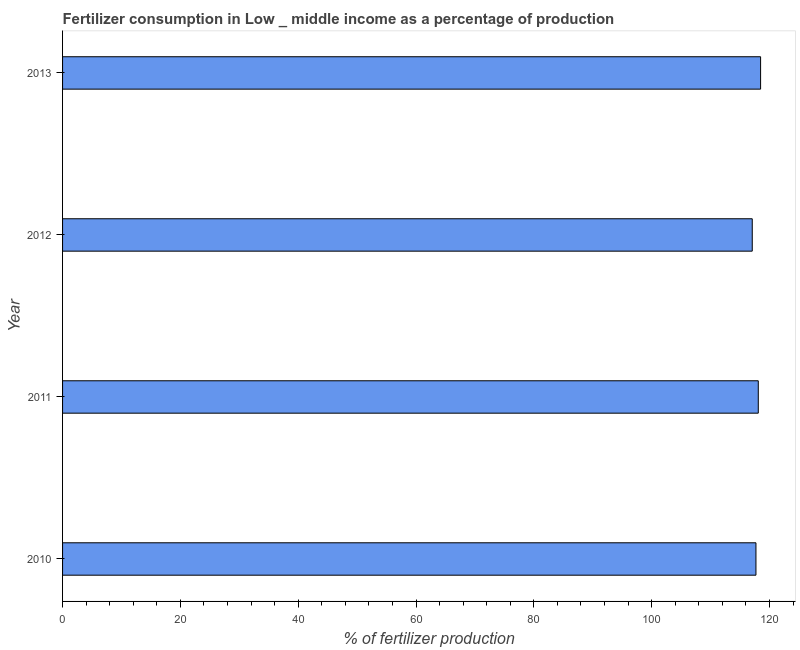Does the graph contain any zero values?
Provide a succinct answer. No. Does the graph contain grids?
Your response must be concise. No. What is the title of the graph?
Provide a short and direct response. Fertilizer consumption in Low _ middle income as a percentage of production. What is the label or title of the X-axis?
Your answer should be compact. % of fertilizer production. What is the label or title of the Y-axis?
Provide a short and direct response. Year. What is the amount of fertilizer consumption in 2012?
Offer a very short reply. 117.07. Across all years, what is the maximum amount of fertilizer consumption?
Offer a terse response. 118.49. Across all years, what is the minimum amount of fertilizer consumption?
Provide a short and direct response. 117.07. In which year was the amount of fertilizer consumption maximum?
Make the answer very short. 2013. What is the sum of the amount of fertilizer consumption?
Keep it short and to the point. 471.36. What is the difference between the amount of fertilizer consumption in 2010 and 2011?
Provide a short and direct response. -0.4. What is the average amount of fertilizer consumption per year?
Your response must be concise. 117.84. What is the median amount of fertilizer consumption?
Provide a succinct answer. 117.9. Do a majority of the years between 2011 and 2012 (inclusive) have amount of fertilizer consumption greater than 64 %?
Give a very brief answer. Yes. What is the difference between the highest and the second highest amount of fertilizer consumption?
Make the answer very short. 0.39. Is the sum of the amount of fertilizer consumption in 2011 and 2013 greater than the maximum amount of fertilizer consumption across all years?
Ensure brevity in your answer.  Yes. What is the difference between the highest and the lowest amount of fertilizer consumption?
Give a very brief answer. 1.42. In how many years, is the amount of fertilizer consumption greater than the average amount of fertilizer consumption taken over all years?
Ensure brevity in your answer.  2. How many bars are there?
Offer a terse response. 4. How many years are there in the graph?
Make the answer very short. 4. What is the % of fertilizer production of 2010?
Provide a succinct answer. 117.7. What is the % of fertilizer production in 2011?
Ensure brevity in your answer.  118.1. What is the % of fertilizer production in 2012?
Give a very brief answer. 117.07. What is the % of fertilizer production in 2013?
Give a very brief answer. 118.49. What is the difference between the % of fertilizer production in 2010 and 2011?
Make the answer very short. -0.4. What is the difference between the % of fertilizer production in 2010 and 2012?
Your response must be concise. 0.63. What is the difference between the % of fertilizer production in 2010 and 2013?
Make the answer very short. -0.79. What is the difference between the % of fertilizer production in 2011 and 2012?
Provide a short and direct response. 1.02. What is the difference between the % of fertilizer production in 2011 and 2013?
Your answer should be very brief. -0.39. What is the difference between the % of fertilizer production in 2012 and 2013?
Your answer should be very brief. -1.42. What is the ratio of the % of fertilizer production in 2010 to that in 2011?
Give a very brief answer. 1. What is the ratio of the % of fertilizer production in 2011 to that in 2012?
Your answer should be very brief. 1.01. What is the ratio of the % of fertilizer production in 2011 to that in 2013?
Your answer should be compact. 1. What is the ratio of the % of fertilizer production in 2012 to that in 2013?
Your answer should be very brief. 0.99. 